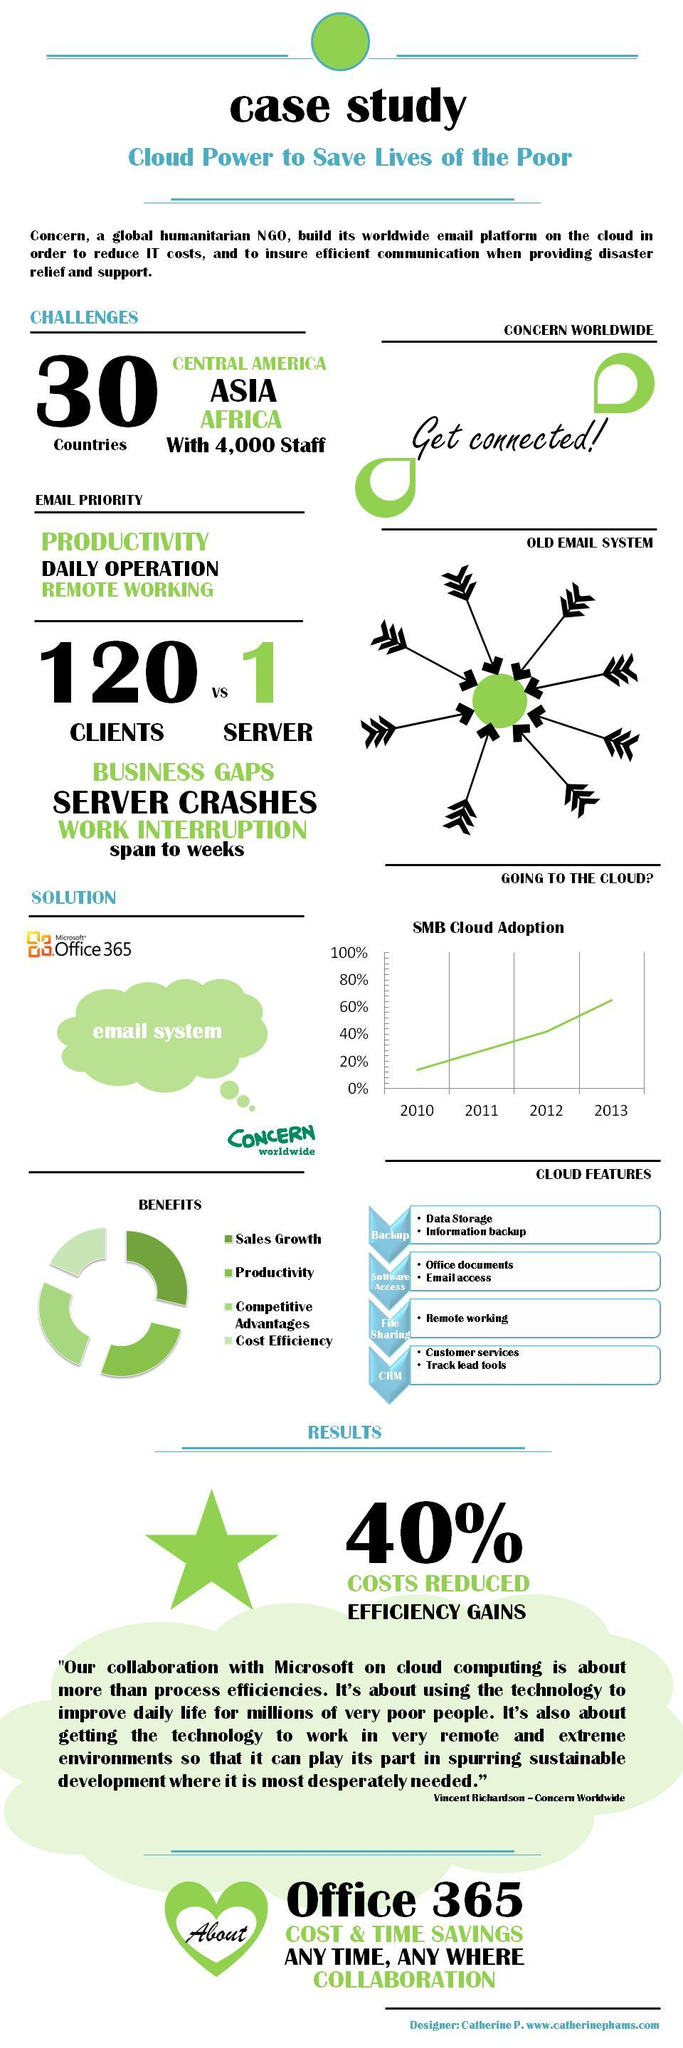How many points are under the heading "Cloud Features"?
Answer the question with a short phrase. 4 How many points are under the heading "Benefits"? 4 